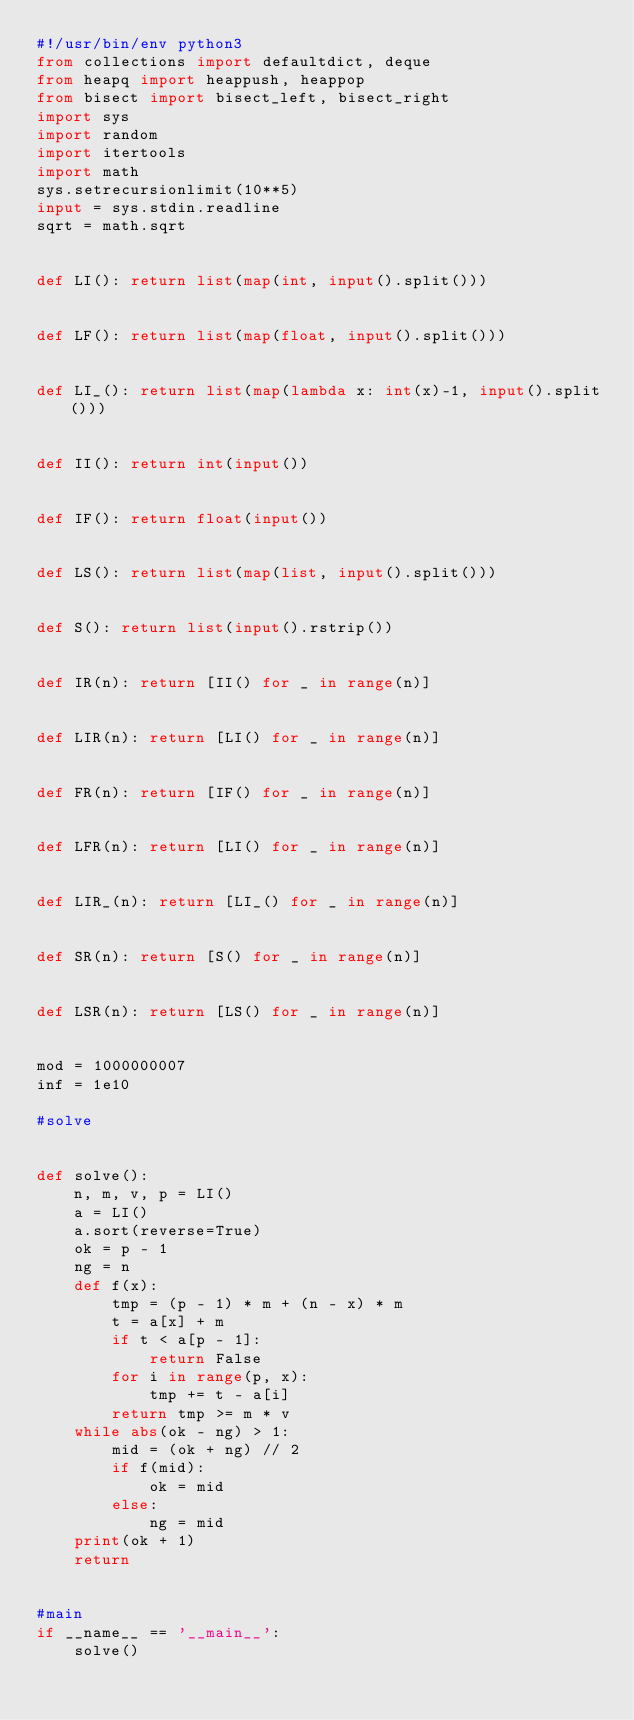Convert code to text. <code><loc_0><loc_0><loc_500><loc_500><_Python_>#!/usr/bin/env python3
from collections import defaultdict, deque
from heapq import heappush, heappop
from bisect import bisect_left, bisect_right
import sys
import random
import itertools
import math
sys.setrecursionlimit(10**5)
input = sys.stdin.readline
sqrt = math.sqrt


def LI(): return list(map(int, input().split()))


def LF(): return list(map(float, input().split()))


def LI_(): return list(map(lambda x: int(x)-1, input().split()))


def II(): return int(input())


def IF(): return float(input())


def LS(): return list(map(list, input().split()))


def S(): return list(input().rstrip())


def IR(n): return [II() for _ in range(n)]


def LIR(n): return [LI() for _ in range(n)]


def FR(n): return [IF() for _ in range(n)]


def LFR(n): return [LI() for _ in range(n)]


def LIR_(n): return [LI_() for _ in range(n)]


def SR(n): return [S() for _ in range(n)]


def LSR(n): return [LS() for _ in range(n)]


mod = 1000000007
inf = 1e10

#solve


def solve():
    n, m, v, p = LI()
    a = LI()
    a.sort(reverse=True)
    ok = p - 1
    ng = n
    def f(x):
        tmp = (p - 1) * m + (n - x) * m
        t = a[x] + m
        if t < a[p - 1]:
            return False
        for i in range(p, x):
            tmp += t - a[i]
        return tmp >= m * v
    while abs(ok - ng) > 1:
        mid = (ok + ng) // 2
        if f(mid):
            ok = mid
        else:
            ng = mid
    print(ok + 1)
    return


#main
if __name__ == '__main__':
    solve()
</code> 